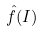<formula> <loc_0><loc_0><loc_500><loc_500>\hat { f } ( I )</formula> 